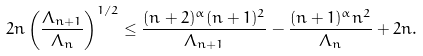Convert formula to latex. <formula><loc_0><loc_0><loc_500><loc_500>2 n \left ( \frac { \Lambda _ { n + 1 } } { \Lambda _ { n } } \right ) ^ { 1 / 2 } \leq \frac { ( n + 2 ) ^ { \alpha } ( n + 1 ) ^ { 2 } } { \Lambda _ { n + 1 } } - \frac { ( n + 1 ) ^ { \alpha } n ^ { 2 } } { \Lambda _ { n } } + 2 n .</formula> 